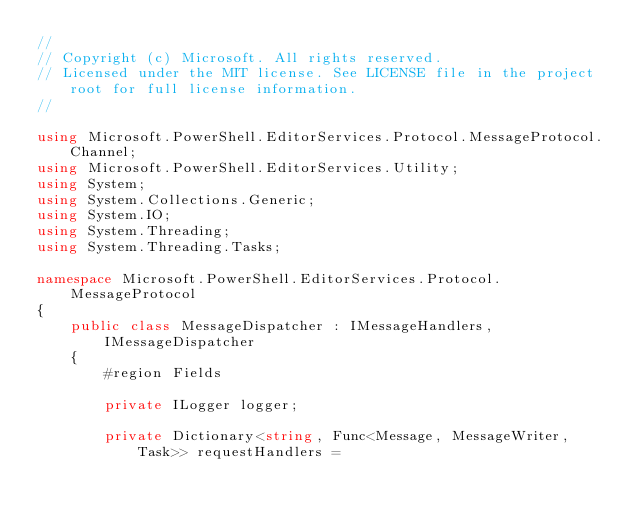Convert code to text. <code><loc_0><loc_0><loc_500><loc_500><_C#_>//
// Copyright (c) Microsoft. All rights reserved.
// Licensed under the MIT license. See LICENSE file in the project root for full license information.
//

using Microsoft.PowerShell.EditorServices.Protocol.MessageProtocol.Channel;
using Microsoft.PowerShell.EditorServices.Utility;
using System;
using System.Collections.Generic;
using System.IO;
using System.Threading;
using System.Threading.Tasks;

namespace Microsoft.PowerShell.EditorServices.Protocol.MessageProtocol
{
    public class MessageDispatcher : IMessageHandlers, IMessageDispatcher
    {
        #region Fields

        private ILogger logger;

        private Dictionary<string, Func<Message, MessageWriter, Task>> requestHandlers =</code> 